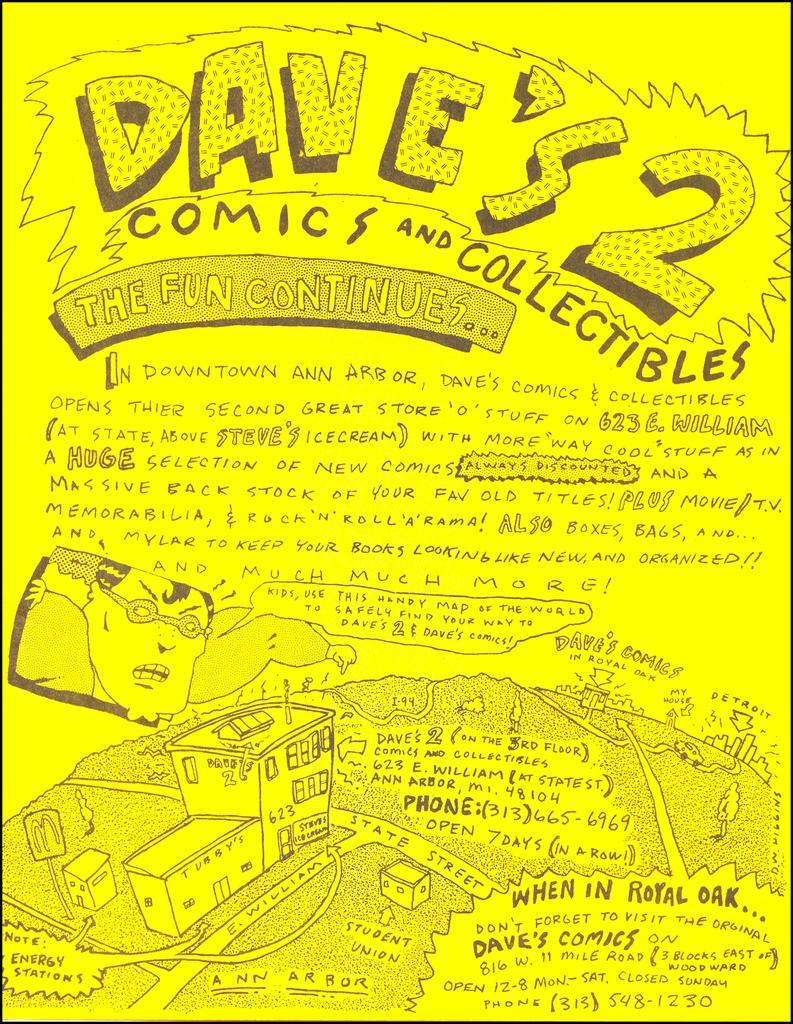Please provide a concise description of this image. In this image we can see a poster with cartoons and some text on it. 